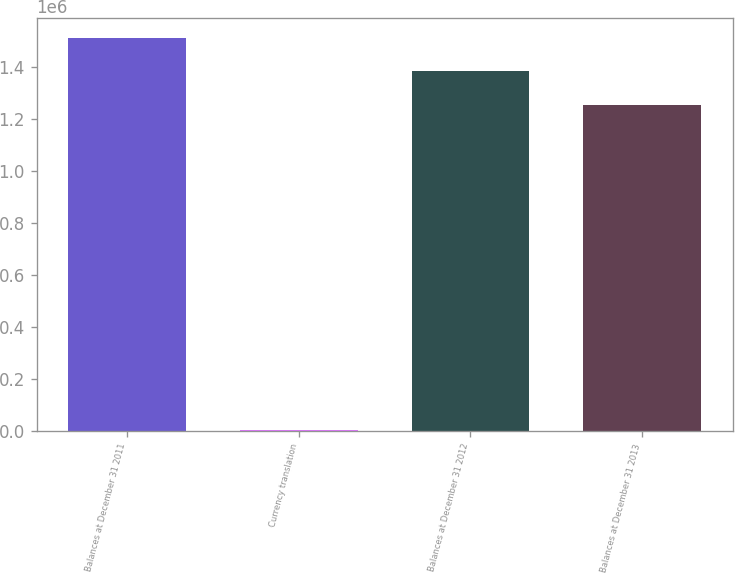<chart> <loc_0><loc_0><loc_500><loc_500><bar_chart><fcel>Balances at December 31 2011<fcel>Currency translation<fcel>Balances at December 31 2012<fcel>Balances at December 31 2013<nl><fcel>1.51065e+06<fcel>3395<fcel>1.38247e+06<fcel>1.25429e+06<nl></chart> 